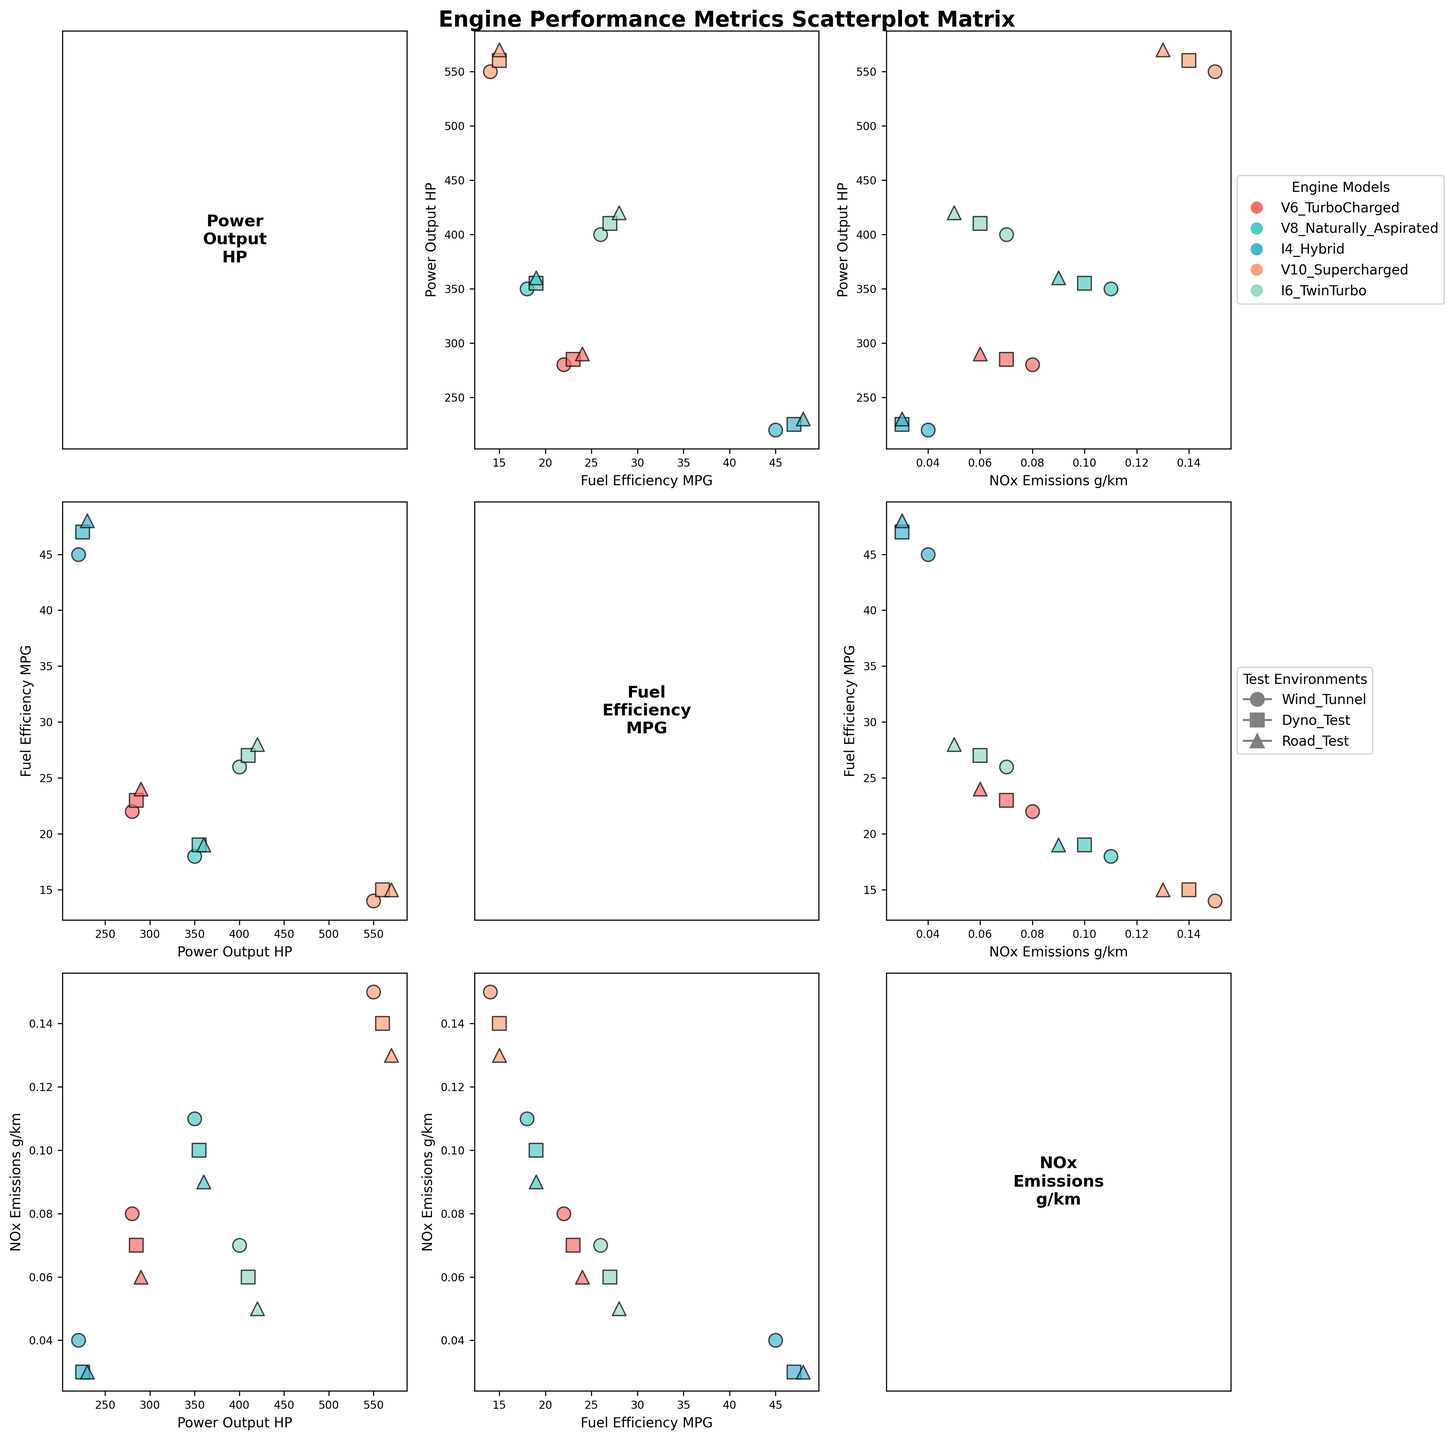What are the axis labels for the scatterplot matrix? The scatterplot matrix includes several axes each labeled with performance metrics. The labels are 'Power Output HP', 'Fuel Efficiency MPG', and 'NOx Emissions g/km'. Specifically, each subplot has different combinations of these labels as x and y axes.
Answer: 'Power Output HP', 'Fuel Efficiency MPG', 'NOx Emissions g/km' Which engine model shows the highest power output? By checking the scatter plots, the V10 Supercharged engine reaches the highest value in the Power Output HP axis, with a value of 570 HP in the Road Test environment.
Answer: V10 Supercharged How does NOx Emissions compare for the I4 Hybrid model between the Wind Tunnel and Road Test environments? For the I4 Hybrid model, the NOx Emissions in the Wind Tunnel is 0.04 g/km, and in the Road Test, it is 0.03 g/km.
Answer: Wind Tunnel: 0.04 g/km, Road Test: 0.03 g/km Which test environment leads to the highest Fuel Efficiency for the I6 TwinTurbo model? The scatter plot shows points for the I6 TwinTurbo model across different environments. The highest Fuel Efficiency of 28 MPG occurred in the Road Test environment.
Answer: Road Test What is the relationship between Fuel Efficiency and Power Output across all engine models? In the scatter plot matrix, the relationships can be examined. Generally, there's an inverse relationship: higher Fuel Efficiency tends to correspond with lower Power Output, and vice versa.
Answer: Inverse relationship For the V8 Naturally Aspirated engine, how much does the Power Output increase from the Wind Tunnel to the Road Test environment? The Power Output for the V8 Naturally Aspirated engine is 350 HP in the Wind Tunnel and 360 HP in the Road Test. The increase is 360 - 350 = 10 HP.
Answer: 10 HP Does the I4 Hybrid model ever exceed a Fuel Efficiency of 45 MPG? Yes, the I4 Hybrid model exceeds a Fuel Efficiency of 45 MPG in all testing environments: Wind Tunnel (45 MPG), Dyno Test (47 MPG), and Road Test (48 MPG).
Answer: Yes Which engine model has the lowest NOx Emissions in the Road Test environment? By examining the respective scatter points in the NOx Emissions subplots, the I4 Hybrid has the lowest NOx Emissions in the Road Test environment with 0.03 g/km.
Answer: I4 Hybrid Are there any test environments where the V6 TurboCharged model achieves both high Power Output and high Fuel Efficiency? The scatterplot data points show that in the Road Test environment, the V6 TurboCharged model achieves both relatively high Power Output (290 HP) and Fuel Efficiency (24 MPG).
Answer: Road Test 